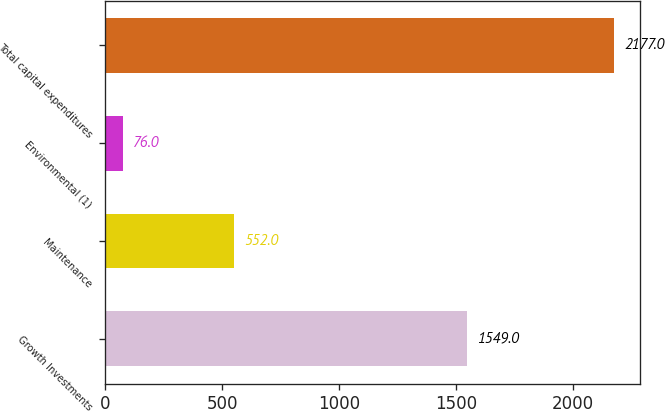<chart> <loc_0><loc_0><loc_500><loc_500><bar_chart><fcel>Growth Investments<fcel>Maintenance<fcel>Environmental (1)<fcel>Total capital expenditures<nl><fcel>1549<fcel>552<fcel>76<fcel>2177<nl></chart> 